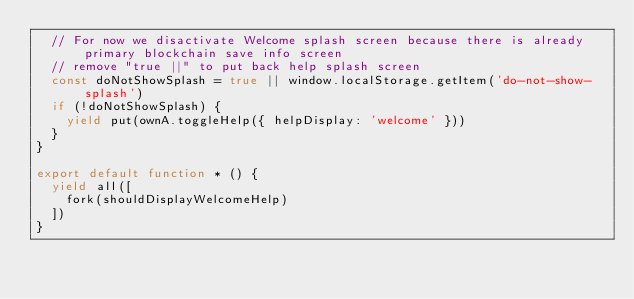<code> <loc_0><loc_0><loc_500><loc_500><_JavaScript_>  // For now we disactivate Welcome splash screen because there is already primary blockchain save info screen
  // remove "true ||" to put back help splash screen
  const doNotShowSplash = true || window.localStorage.getItem('do-not-show-splash')
  if (!doNotShowSplash) {
    yield put(ownA.toggleHelp({ helpDisplay: 'welcome' }))
  }
}

export default function * () {
  yield all([
    fork(shouldDisplayWelcomeHelp)
  ])
}
</code> 